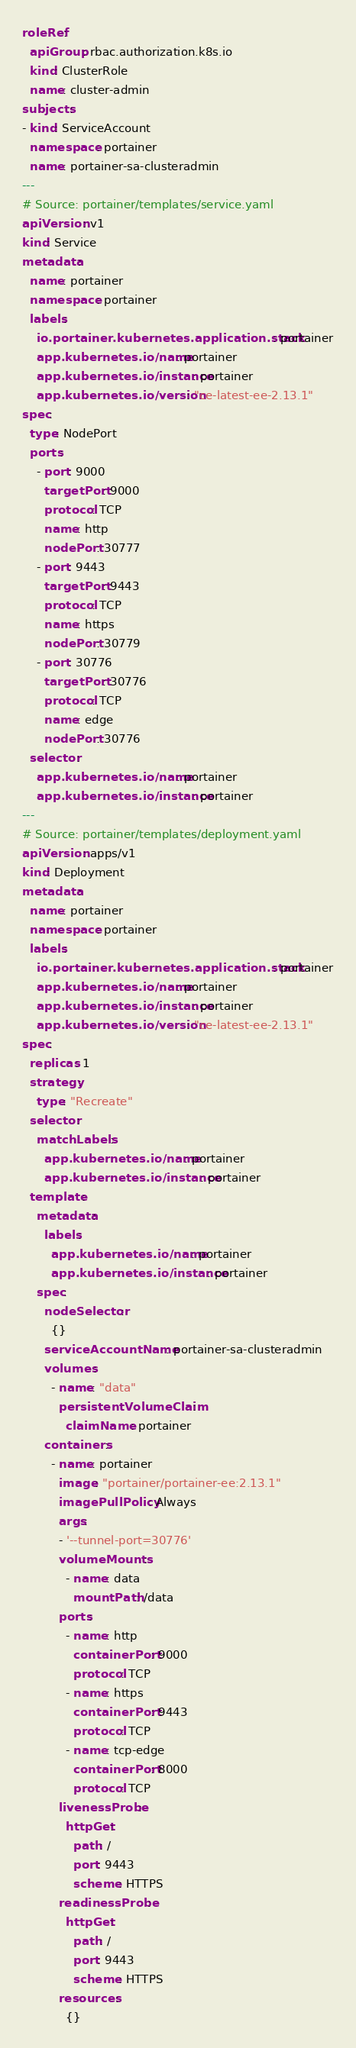<code> <loc_0><loc_0><loc_500><loc_500><_YAML_>roleRef:
  apiGroup: rbac.authorization.k8s.io
  kind: ClusterRole
  name: cluster-admin
subjects:
- kind: ServiceAccount
  namespace: portainer
  name: portainer-sa-clusteradmin
---
# Source: portainer/templates/service.yaml
apiVersion: v1
kind: Service
metadata:
  name: portainer
  namespace: portainer
  labels:
    io.portainer.kubernetes.application.stack: portainer
    app.kubernetes.io/name: portainer
    app.kubernetes.io/instance: portainer
    app.kubernetes.io/version: "ce-latest-ee-2.13.1"
spec:
  type: NodePort
  ports:
    - port: 9000
      targetPort: 9000
      protocol: TCP
      name: http
      nodePort: 30777  
    - port: 9443
      targetPort: 9443
      protocol: TCP
      name: https
      nodePort: 30779      
    - port: 30776
      targetPort: 30776
      protocol: TCP
      name: edge
      nodePort: 30776
  selector:
    app.kubernetes.io/name: portainer
    app.kubernetes.io/instance: portainer
---
# Source: portainer/templates/deployment.yaml
apiVersion: apps/v1
kind: Deployment
metadata:
  name: portainer
  namespace: portainer
  labels:
    io.portainer.kubernetes.application.stack: portainer
    app.kubernetes.io/name: portainer
    app.kubernetes.io/instance: portainer
    app.kubernetes.io/version: "ce-latest-ee-2.13.1"
spec:
  replicas: 1
  strategy:
    type: "Recreate"
  selector:
    matchLabels:
      app.kubernetes.io/name: portainer
      app.kubernetes.io/instance: portainer
  template:
    metadata:
      labels:
        app.kubernetes.io/name: portainer
        app.kubernetes.io/instance: portainer
    spec:
      nodeSelector:
        {}
      serviceAccountName: portainer-sa-clusteradmin
      volumes:
        - name: "data"
          persistentVolumeClaim:
            claimName: portainer
      containers:
        - name: portainer
          image: "portainer/portainer-ee:2.13.1"
          imagePullPolicy: Always
          args:
          - '--tunnel-port=30776'          
          volumeMounts:
            - name: data
              mountPath: /data              
          ports:
            - name: http
              containerPort: 9000
              protocol: TCP
            - name: https
              containerPort: 9443
              protocol: TCP                
            - name: tcp-edge
              containerPort: 8000
              protocol: TCP              
          livenessProbe:
            httpGet:
              path: /
              port: 9443
              scheme: HTTPS
          readinessProbe:
            httpGet:
              path: /
              port: 9443
              scheme: HTTPS        
          resources:
            {}

</code> 